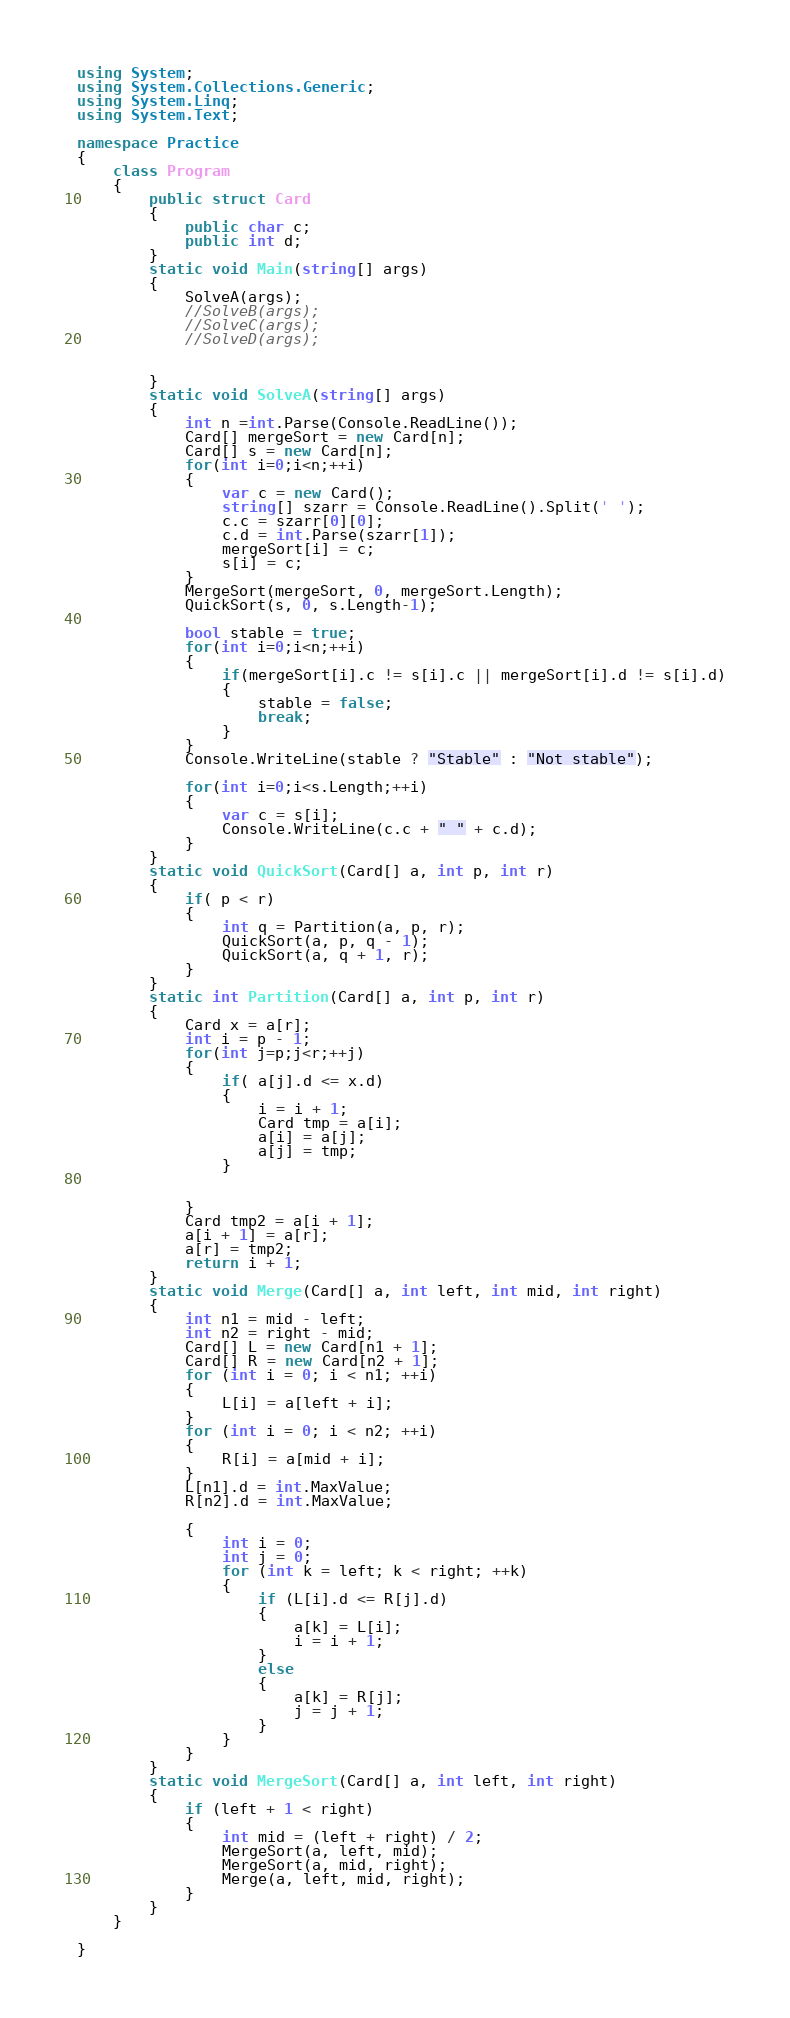<code> <loc_0><loc_0><loc_500><loc_500><_C#_>using System;
using System.Collections.Generic;
using System.Linq;
using System.Text;

namespace Practice
{
    class Program
    {
        public struct Card
        {
            public char c;
            public int d;
        }
        static void Main(string[] args)
        {
            SolveA(args);
            //SolveB(args);
            //SolveC(args);
            //SolveD(args);


        }
        static void SolveA(string[] args)
        {
            int n =int.Parse(Console.ReadLine());
            Card[] mergeSort = new Card[n];
            Card[] s = new Card[n];
            for(int i=0;i<n;++i)
            {
                var c = new Card();
                string[] szarr = Console.ReadLine().Split(' ');
                c.c = szarr[0][0];
                c.d = int.Parse(szarr[1]);
                mergeSort[i] = c;
                s[i] = c;
            }
            MergeSort(mergeSort, 0, mergeSort.Length);
            QuickSort(s, 0, s.Length-1);

            bool stable = true;
            for(int i=0;i<n;++i)
            {
                if(mergeSort[i].c != s[i].c || mergeSort[i].d != s[i].d)
                {
                    stable = false;
                    break;
                }
            }
            Console.WriteLine(stable ? "Stable" : "Not stable");

            for(int i=0;i<s.Length;++i)
            {
                var c = s[i];
                Console.WriteLine(c.c + " " + c.d);
            }
        }
        static void QuickSort(Card[] a, int p, int r)
        {
            if( p < r)
            {
                int q = Partition(a, p, r);
                QuickSort(a, p, q - 1);
                QuickSort(a, q + 1, r);
            }
        }
        static int Partition(Card[] a, int p, int r)
        {
            Card x = a[r];
            int i = p - 1;
            for(int j=p;j<r;++j)
            {
                if( a[j].d <= x.d)
                {
                    i = i + 1;
                    Card tmp = a[i];
                    a[i] = a[j];
                    a[j] = tmp;
                }


            }
            Card tmp2 = a[i + 1];
            a[i + 1] = a[r];
            a[r] = tmp2;
            return i + 1;
        }
        static void Merge(Card[] a, int left, int mid, int right)
        {
            int n1 = mid - left;
            int n2 = right - mid;
            Card[] L = new Card[n1 + 1];
            Card[] R = new Card[n2 + 1];
            for (int i = 0; i < n1; ++i)
            {
                L[i] = a[left + i];
            }
            for (int i = 0; i < n2; ++i)
            {
                R[i] = a[mid + i];
            }
            L[n1].d = int.MaxValue;
            R[n2].d = int.MaxValue;

            {
                int i = 0;
                int j = 0;
                for (int k = left; k < right; ++k)
                {
                    if (L[i].d <= R[j].d)
                    {
                        a[k] = L[i];
                        i = i + 1;
                    }
                    else
                    {
                        a[k] = R[j];
                        j = j + 1;
                    }
                }
            }
        }
        static void MergeSort(Card[] a, int left, int right)
        {
            if (left + 1 < right)
            {
                int mid = (left + right) / 2;
                MergeSort(a, left, mid);
                MergeSort(a, mid, right);
                Merge(a, left, mid, right);
            }
        }
    }

}

</code> 